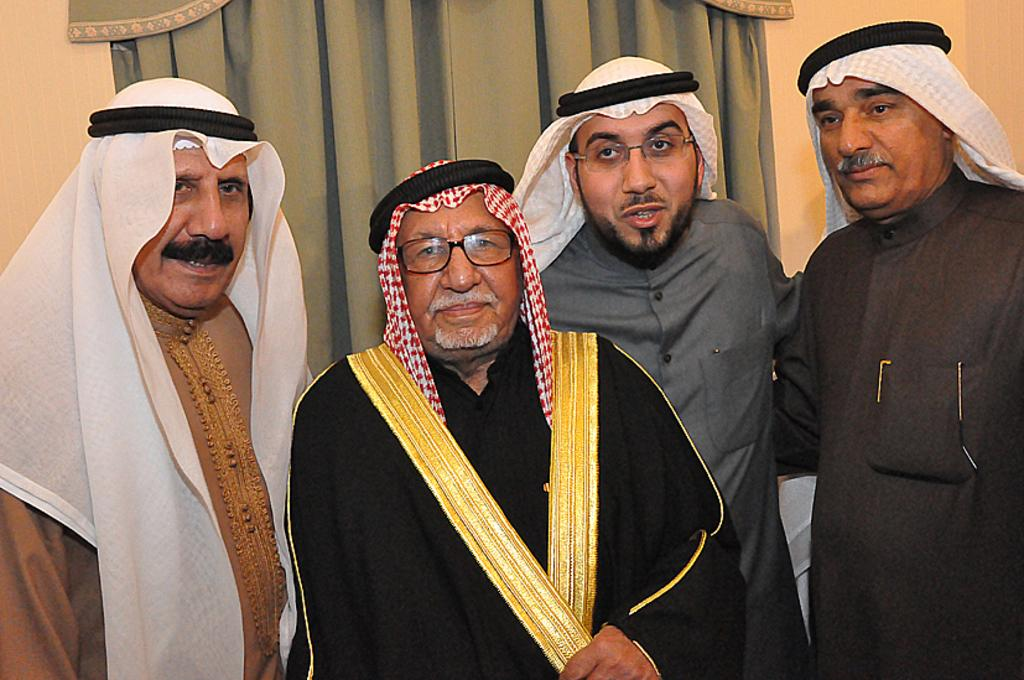How many people are in the image? There are four Arab men in the image. Where are the men located in the image? The men are standing in the front of the image. What can be seen in the background of the image? There is a wall in the background of the image. Is there any decoration on the wall in the background? Yes, there is a curtain on the wall in the background. What color is the bean on the wall in the image? There is no bean present in the image; it only features four Arab men and a curtain on the wall in the background. 